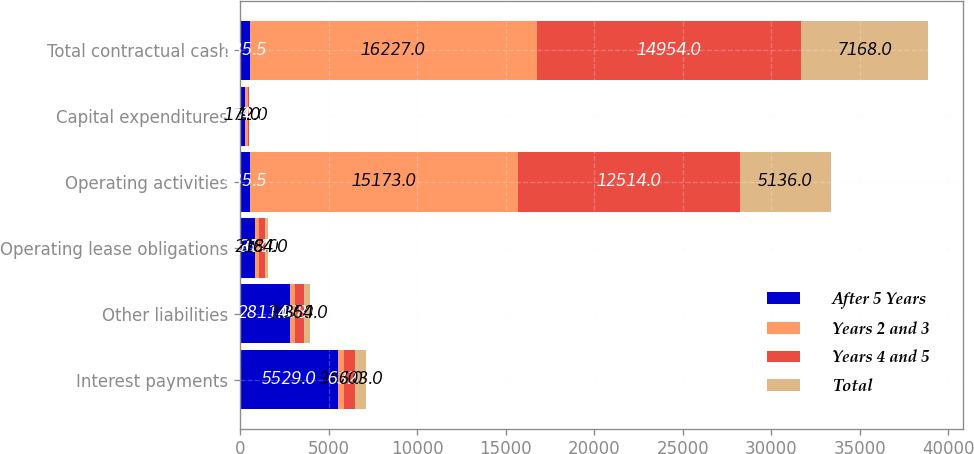Convert chart. <chart><loc_0><loc_0><loc_500><loc_500><stacked_bar_chart><ecel><fcel>Interest payments<fcel>Other liabilities<fcel>Operating lease obligations<fcel>Operating activities<fcel>Capital expenditures<fcel>Total contractual cash<nl><fcel>After 5 Years<fcel>5529<fcel>2811<fcel>856<fcel>535.5<fcel>248<fcel>535.5<nl><fcel>Years 2 and 3<fcel>347<fcel>307<fcel>228<fcel>15173<fcel>172<fcel>16227<nl><fcel>Years 4 and 5<fcel>632<fcel>468<fcel>314<fcel>12514<fcel>74<fcel>14954<nl><fcel>Total<fcel>603<fcel>364<fcel>164<fcel>5136<fcel>1<fcel>7168<nl></chart> 